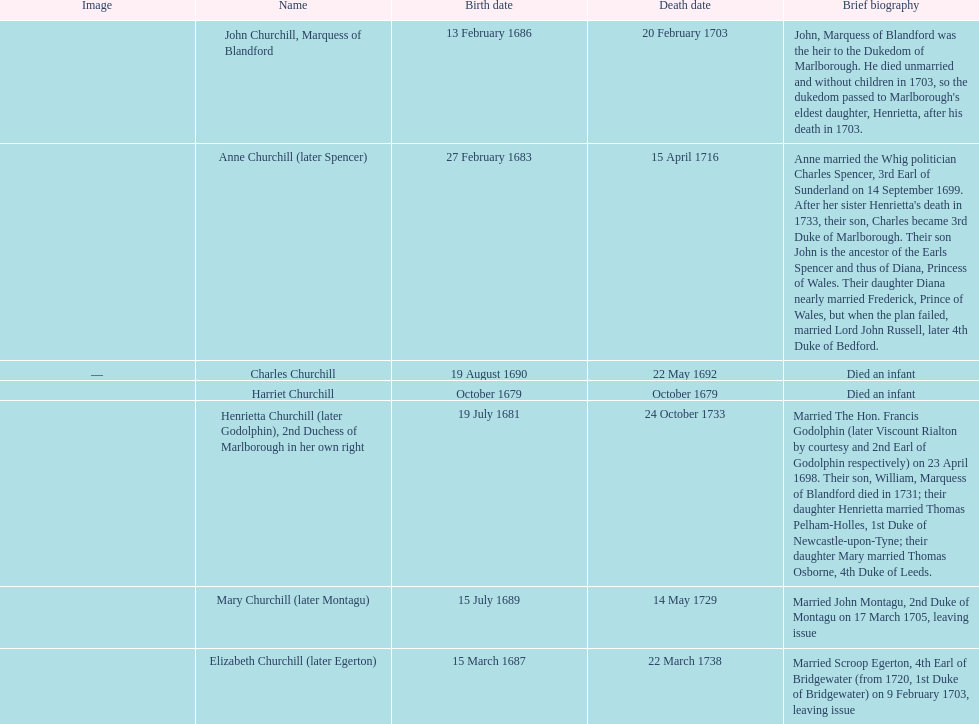Can you parse all the data within this table? {'header': ['Image', 'Name', 'Birth date', 'Death date', 'Brief biography'], 'rows': [['', 'John Churchill, Marquess of Blandford', '13 February 1686', '20 February 1703', "John, Marquess of Blandford was the heir to the Dukedom of Marlborough. He died unmarried and without children in 1703, so the dukedom passed to Marlborough's eldest daughter, Henrietta, after his death in 1703."], ['', 'Anne Churchill (later Spencer)', '27 February 1683', '15 April 1716', "Anne married the Whig politician Charles Spencer, 3rd Earl of Sunderland on 14 September 1699. After her sister Henrietta's death in 1733, their son, Charles became 3rd Duke of Marlborough. Their son John is the ancestor of the Earls Spencer and thus of Diana, Princess of Wales. Their daughter Diana nearly married Frederick, Prince of Wales, but when the plan failed, married Lord John Russell, later 4th Duke of Bedford."], ['—', 'Charles Churchill', '19 August 1690', '22 May 1692', 'Died an infant'], ['', 'Harriet Churchill', 'October 1679', 'October 1679', 'Died an infant'], ['', 'Henrietta Churchill (later Godolphin), 2nd Duchess of Marlborough in her own right', '19 July 1681', '24 October 1733', 'Married The Hon. Francis Godolphin (later Viscount Rialton by courtesy and 2nd Earl of Godolphin respectively) on 23 April 1698. Their son, William, Marquess of Blandford died in 1731; their daughter Henrietta married Thomas Pelham-Holles, 1st Duke of Newcastle-upon-Tyne; their daughter Mary married Thomas Osborne, 4th Duke of Leeds.'], ['', 'Mary Churchill (later Montagu)', '15 July 1689', '14 May 1729', 'Married John Montagu, 2nd Duke of Montagu on 17 March 1705, leaving issue'], ['', 'Elizabeth Churchill (later Egerton)', '15 March 1687', '22 March 1738', 'Married Scroop Egerton, 4th Earl of Bridgewater (from 1720, 1st Duke of Bridgewater) on 9 February 1703, leaving issue']]} What is the total number of children born after 1675? 7. 